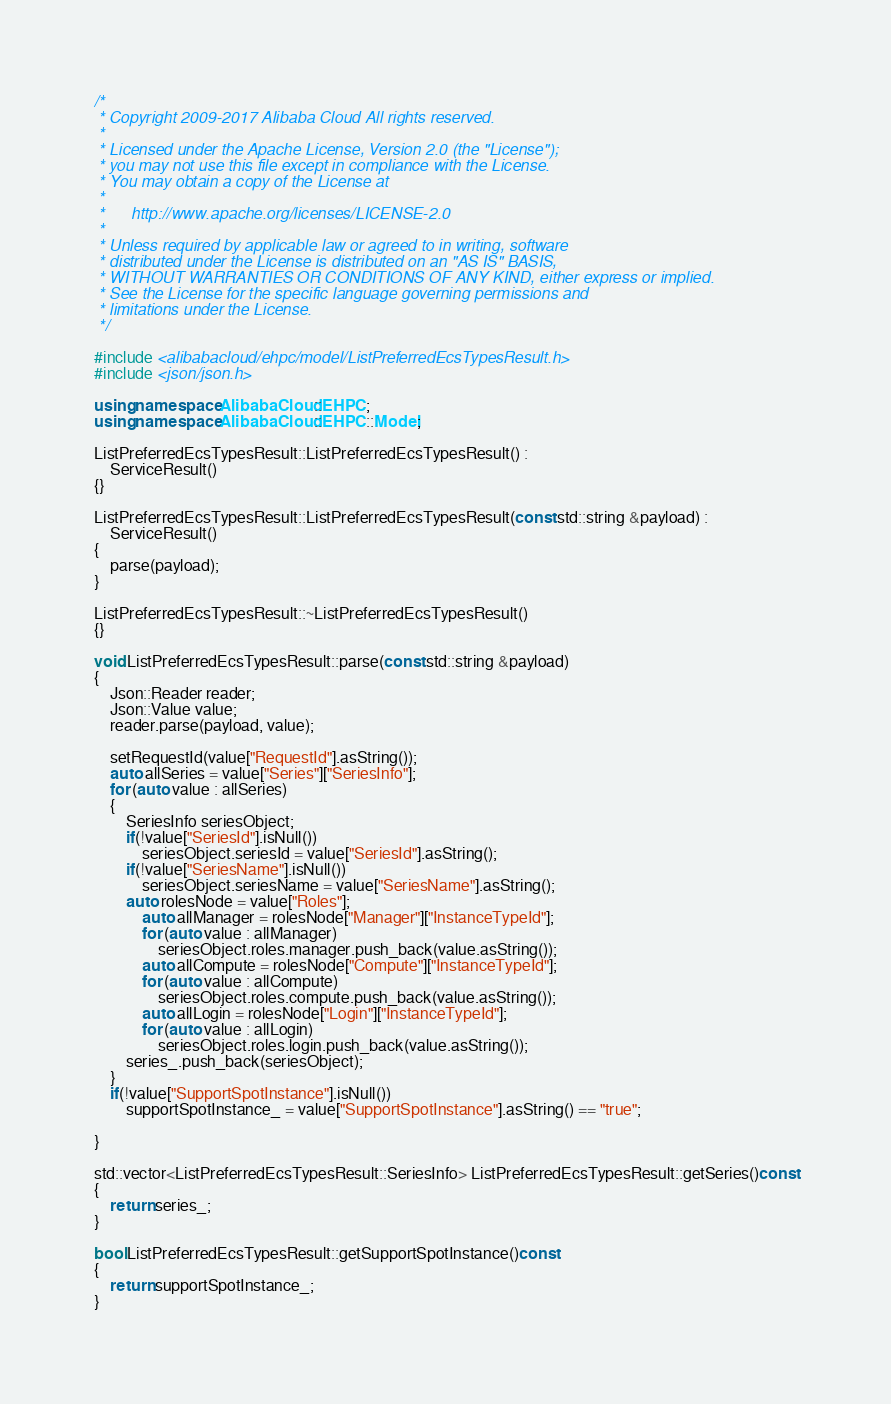<code> <loc_0><loc_0><loc_500><loc_500><_C++_>/*
 * Copyright 2009-2017 Alibaba Cloud All rights reserved.
 * 
 * Licensed under the Apache License, Version 2.0 (the "License");
 * you may not use this file except in compliance with the License.
 * You may obtain a copy of the License at
 * 
 *      http://www.apache.org/licenses/LICENSE-2.0
 * 
 * Unless required by applicable law or agreed to in writing, software
 * distributed under the License is distributed on an "AS IS" BASIS,
 * WITHOUT WARRANTIES OR CONDITIONS OF ANY KIND, either express or implied.
 * See the License for the specific language governing permissions and
 * limitations under the License.
 */

#include <alibabacloud/ehpc/model/ListPreferredEcsTypesResult.h>
#include <json/json.h>

using namespace AlibabaCloud::EHPC;
using namespace AlibabaCloud::EHPC::Model;

ListPreferredEcsTypesResult::ListPreferredEcsTypesResult() :
	ServiceResult()
{}

ListPreferredEcsTypesResult::ListPreferredEcsTypesResult(const std::string &payload) :
	ServiceResult()
{
	parse(payload);
}

ListPreferredEcsTypesResult::~ListPreferredEcsTypesResult()
{}

void ListPreferredEcsTypesResult::parse(const std::string &payload)
{
	Json::Reader reader;
	Json::Value value;
	reader.parse(payload, value);

	setRequestId(value["RequestId"].asString());
	auto allSeries = value["Series"]["SeriesInfo"];
	for (auto value : allSeries)
	{
		SeriesInfo seriesObject;
		if(!value["SeriesId"].isNull())
			seriesObject.seriesId = value["SeriesId"].asString();
		if(!value["SeriesName"].isNull())
			seriesObject.seriesName = value["SeriesName"].asString();
		auto rolesNode = value["Roles"];
			auto allManager = rolesNode["Manager"]["InstanceTypeId"];
			for (auto value : allManager)
				seriesObject.roles.manager.push_back(value.asString());
			auto allCompute = rolesNode["Compute"]["InstanceTypeId"];
			for (auto value : allCompute)
				seriesObject.roles.compute.push_back(value.asString());
			auto allLogin = rolesNode["Login"]["InstanceTypeId"];
			for (auto value : allLogin)
				seriesObject.roles.login.push_back(value.asString());
		series_.push_back(seriesObject);
	}
	if(!value["SupportSpotInstance"].isNull())
		supportSpotInstance_ = value["SupportSpotInstance"].asString() == "true";

}

std::vector<ListPreferredEcsTypesResult::SeriesInfo> ListPreferredEcsTypesResult::getSeries()const
{
	return series_;
}

bool ListPreferredEcsTypesResult::getSupportSpotInstance()const
{
	return supportSpotInstance_;
}

</code> 